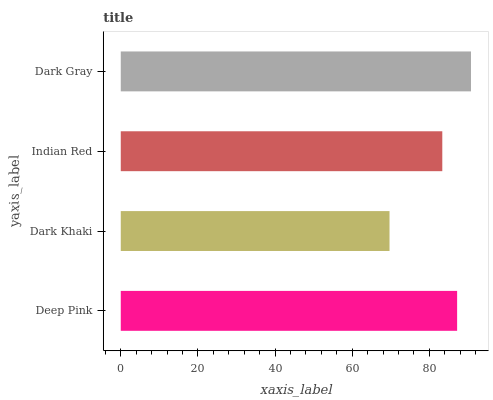Is Dark Khaki the minimum?
Answer yes or no. Yes. Is Dark Gray the maximum?
Answer yes or no. Yes. Is Indian Red the minimum?
Answer yes or no. No. Is Indian Red the maximum?
Answer yes or no. No. Is Indian Red greater than Dark Khaki?
Answer yes or no. Yes. Is Dark Khaki less than Indian Red?
Answer yes or no. Yes. Is Dark Khaki greater than Indian Red?
Answer yes or no. No. Is Indian Red less than Dark Khaki?
Answer yes or no. No. Is Deep Pink the high median?
Answer yes or no. Yes. Is Indian Red the low median?
Answer yes or no. Yes. Is Dark Gray the high median?
Answer yes or no. No. Is Deep Pink the low median?
Answer yes or no. No. 